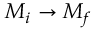<formula> <loc_0><loc_0><loc_500><loc_500>M _ { i } \rightarrow M _ { f }</formula> 